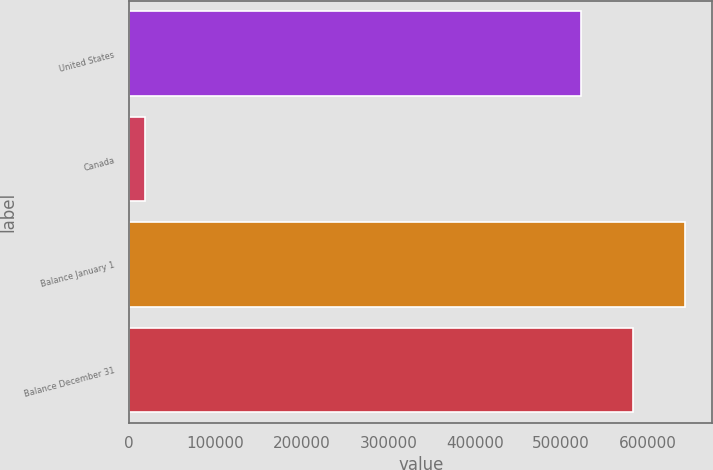Convert chart to OTSL. <chart><loc_0><loc_0><loc_500><loc_500><bar_chart><fcel>United States<fcel>Canada<fcel>Balance January 1<fcel>Balance December 31<nl><fcel>523324<fcel>18706<fcel>642680<fcel>583002<nl></chart> 